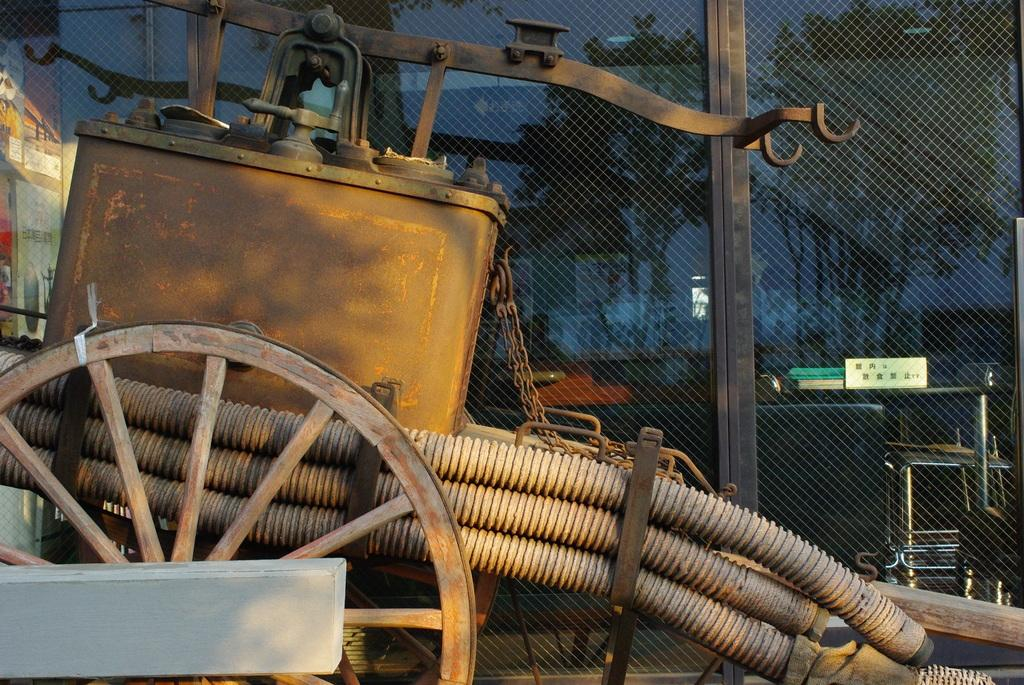What can be observed about the background of the image? The background portion of the picture is blurry. What type of natural elements can be seen in the image? There are trees visible in the image. What other unspecified objects are present in the image? There are unspecified objects in the image. Can you describe a specific feature in the image? There is a mesh in the image. What type of man-made structures can be seen in the image? There are pipes in the image. What is the machine in the image placed on? There is a machine placed in a cart in the image. What type of rake is being used to look for pears in the image? There is no rake or pears present in the image. How does the machine in the cart look at the trees in the image? The machine in the cart does not have the ability to look at the trees, as it is an inanimate object. 